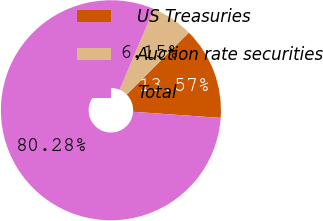Convert chart. <chart><loc_0><loc_0><loc_500><loc_500><pie_chart><fcel>US Treasuries<fcel>Auction rate securities<fcel>Total<nl><fcel>13.57%<fcel>6.15%<fcel>80.28%<nl></chart> 